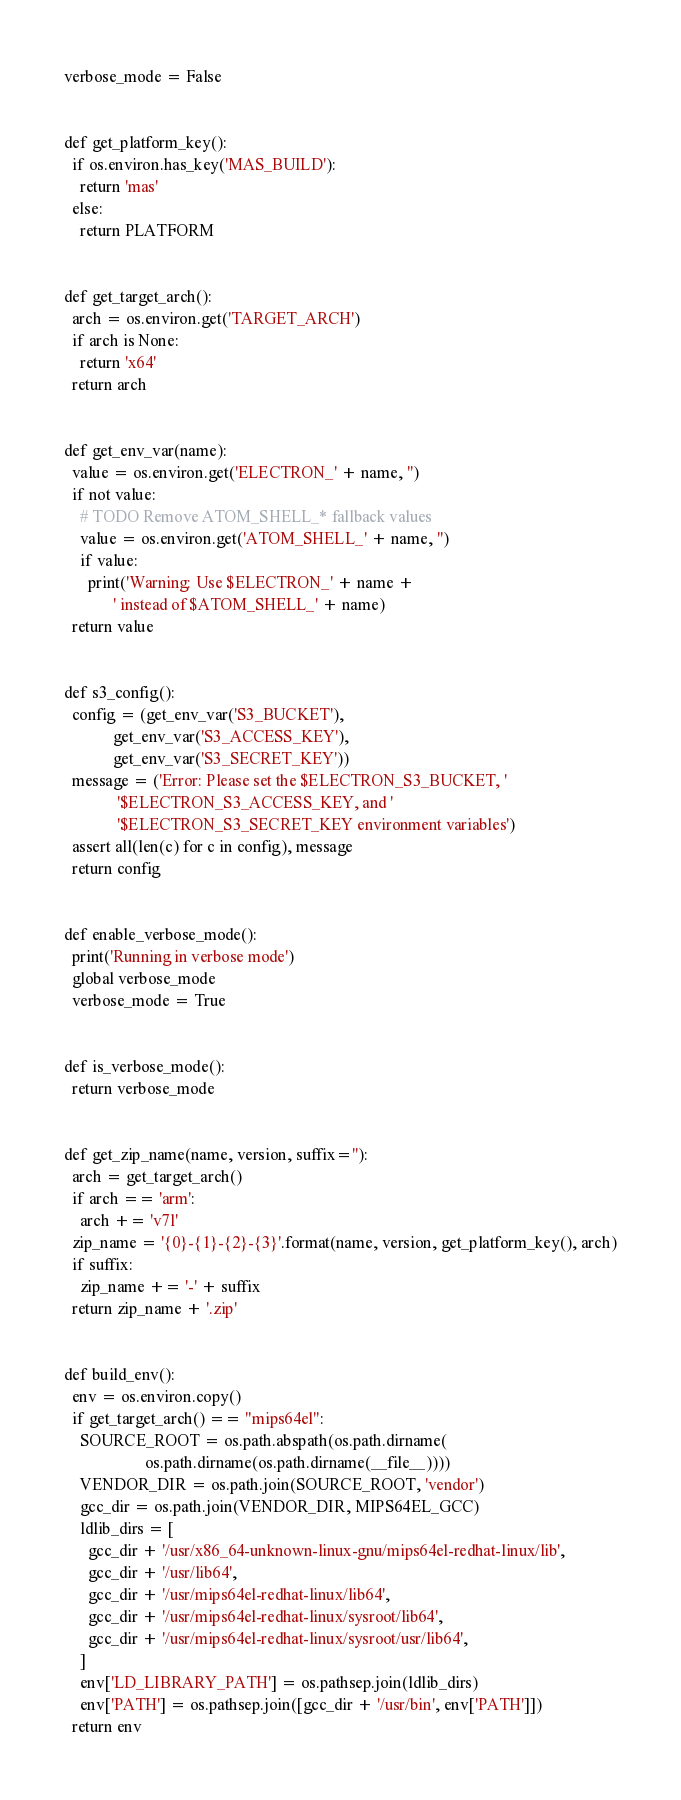<code> <loc_0><loc_0><loc_500><loc_500><_Python_>
verbose_mode = False


def get_platform_key():
  if os.environ.has_key('MAS_BUILD'):
    return 'mas'
  else:
    return PLATFORM


def get_target_arch():
  arch = os.environ.get('TARGET_ARCH')
  if arch is None:
    return 'x64'
  return arch


def get_env_var(name):
  value = os.environ.get('ELECTRON_' + name, '')
  if not value:
    # TODO Remove ATOM_SHELL_* fallback values
    value = os.environ.get('ATOM_SHELL_' + name, '')
    if value:
      print('Warning: Use $ELECTRON_' + name +
            ' instead of $ATOM_SHELL_' + name)
  return value


def s3_config():
  config = (get_env_var('S3_BUCKET'),
            get_env_var('S3_ACCESS_KEY'),
            get_env_var('S3_SECRET_KEY'))
  message = ('Error: Please set the $ELECTRON_S3_BUCKET, '
             '$ELECTRON_S3_ACCESS_KEY, and '
             '$ELECTRON_S3_SECRET_KEY environment variables')
  assert all(len(c) for c in config), message
  return config


def enable_verbose_mode():
  print('Running in verbose mode')
  global verbose_mode
  verbose_mode = True


def is_verbose_mode():
  return verbose_mode


def get_zip_name(name, version, suffix=''):
  arch = get_target_arch()
  if arch == 'arm':
    arch += 'v7l'
  zip_name = '{0}-{1}-{2}-{3}'.format(name, version, get_platform_key(), arch)
  if suffix:
    zip_name += '-' + suffix
  return zip_name + '.zip'


def build_env():
  env = os.environ.copy()
  if get_target_arch() == "mips64el":
    SOURCE_ROOT = os.path.abspath(os.path.dirname(
                    os.path.dirname(os.path.dirname(__file__))))
    VENDOR_DIR = os.path.join(SOURCE_ROOT, 'vendor')
    gcc_dir = os.path.join(VENDOR_DIR, MIPS64EL_GCC)
    ldlib_dirs = [
      gcc_dir + '/usr/x86_64-unknown-linux-gnu/mips64el-redhat-linux/lib',
      gcc_dir + '/usr/lib64',
      gcc_dir + '/usr/mips64el-redhat-linux/lib64',
      gcc_dir + '/usr/mips64el-redhat-linux/sysroot/lib64',
      gcc_dir + '/usr/mips64el-redhat-linux/sysroot/usr/lib64',
    ]
    env['LD_LIBRARY_PATH'] = os.pathsep.join(ldlib_dirs)
    env['PATH'] = os.pathsep.join([gcc_dir + '/usr/bin', env['PATH']])
  return env
</code> 